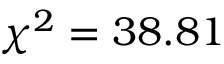Convert formula to latex. <formula><loc_0><loc_0><loc_500><loc_500>\chi ^ { 2 } = 3 8 . 8 1</formula> 